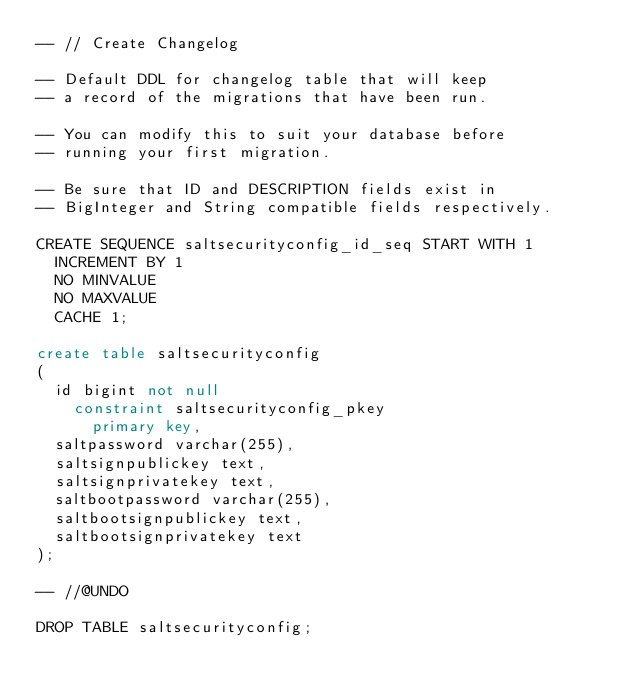Convert code to text. <code><loc_0><loc_0><loc_500><loc_500><_SQL_>-- // Create Changelog

-- Default DDL for changelog table that will keep
-- a record of the migrations that have been run.

-- You can modify this to suit your database before
-- running your first migration.

-- Be sure that ID and DESCRIPTION fields exist in
-- BigInteger and String compatible fields respectively.

CREATE SEQUENCE saltsecurityconfig_id_seq START WITH 1
  INCREMENT BY 1
  NO MINVALUE
  NO MAXVALUE
  CACHE 1;

create table saltsecurityconfig
(
  id bigint not null
    constraint saltsecurityconfig_pkey
      primary key,
  saltpassword varchar(255),
  saltsignpublickey text,
  saltsignprivatekey text,
  saltbootpassword varchar(255),
  saltbootsignpublickey text,
  saltbootsignprivatekey text
);

-- //@UNDO

DROP TABLE saltsecurityconfig;
</code> 